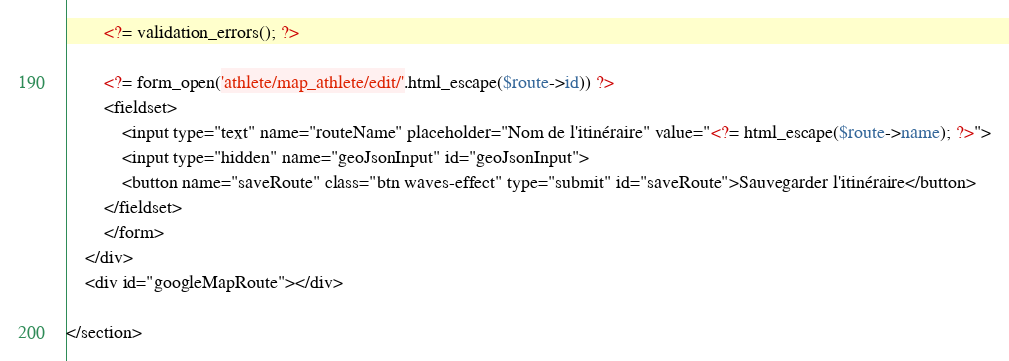<code> <loc_0><loc_0><loc_500><loc_500><_PHP_>        <?= validation_errors(); ?>

        <?= form_open('athlete/map_athlete/edit/'.html_escape($route->id)) ?>
        <fieldset>
            <input type="text" name="routeName" placeholder="Nom de l'itinéraire" value="<?= html_escape($route->name); ?>">
            <input type="hidden" name="geoJsonInput" id="geoJsonInput">
            <button name="saveRoute" class="btn waves-effect" type="submit" id="saveRoute">Sauvegarder l'itinéraire</button>
        </fieldset>
        </form>
    </div>
    <div id="googleMapRoute"></div>

</section></code> 